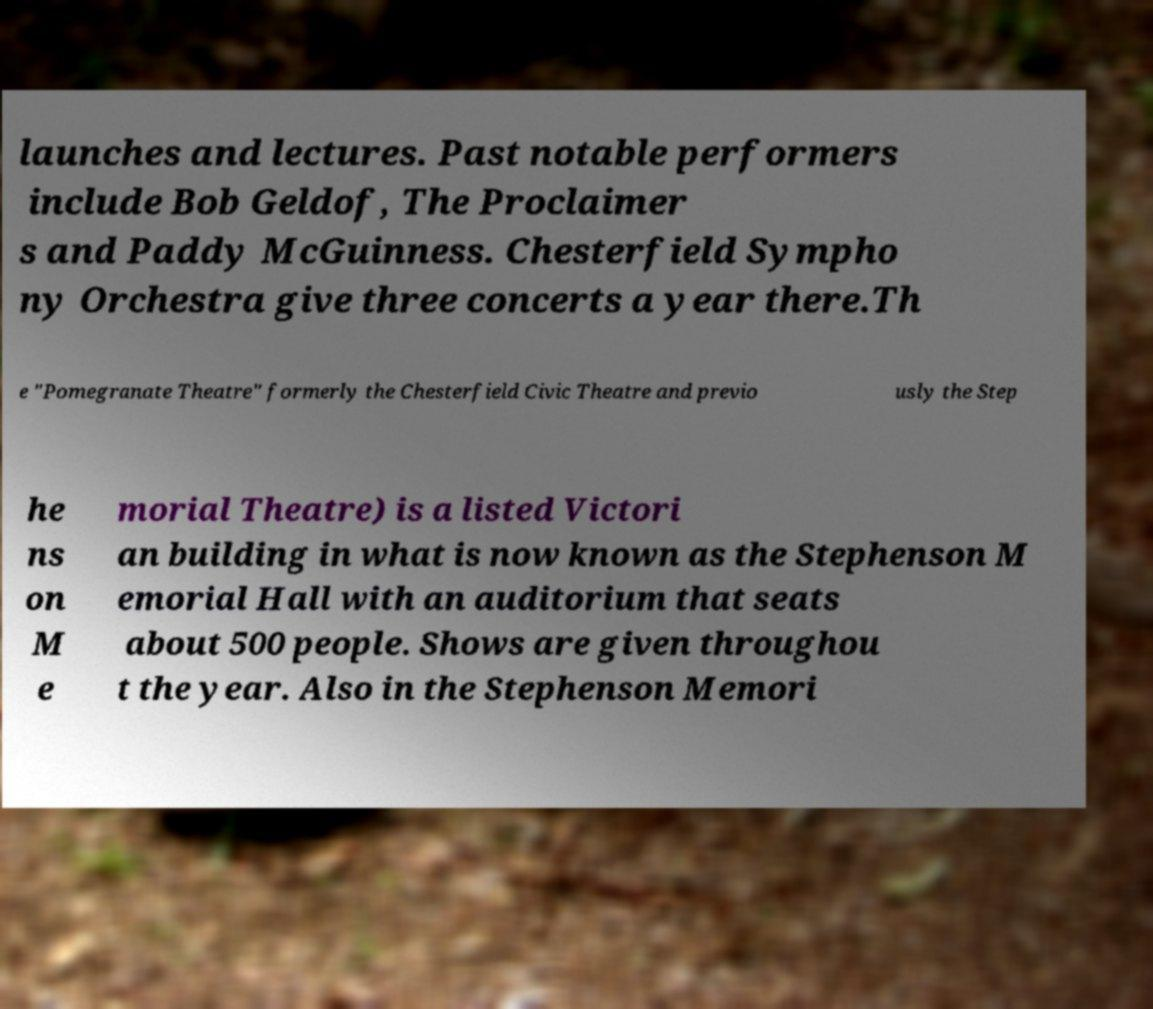What messages or text are displayed in this image? I need them in a readable, typed format. launches and lectures. Past notable performers include Bob Geldof, The Proclaimer s and Paddy McGuinness. Chesterfield Sympho ny Orchestra give three concerts a year there.Th e "Pomegranate Theatre" formerly the Chesterfield Civic Theatre and previo usly the Step he ns on M e morial Theatre) is a listed Victori an building in what is now known as the Stephenson M emorial Hall with an auditorium that seats about 500 people. Shows are given throughou t the year. Also in the Stephenson Memori 